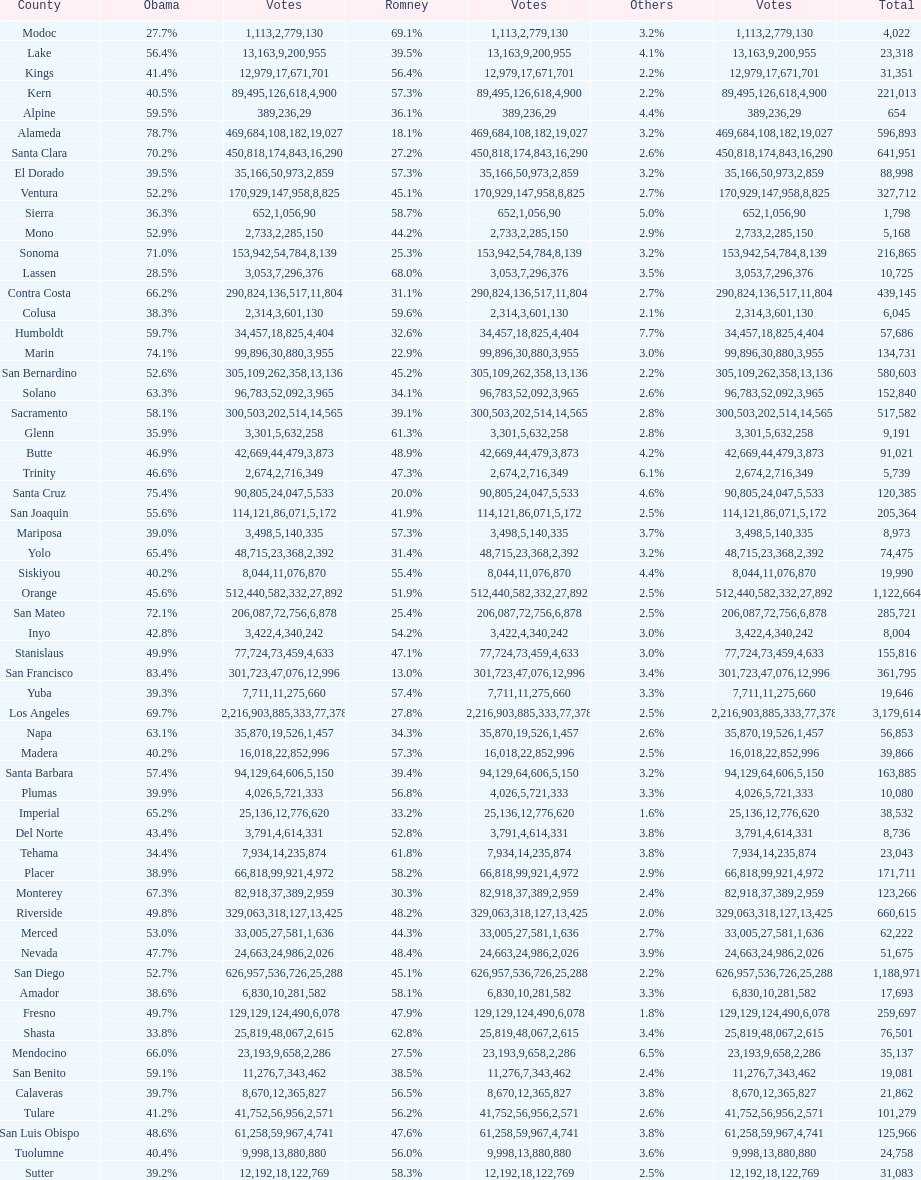Which county had the most total votes? Los Angeles. 